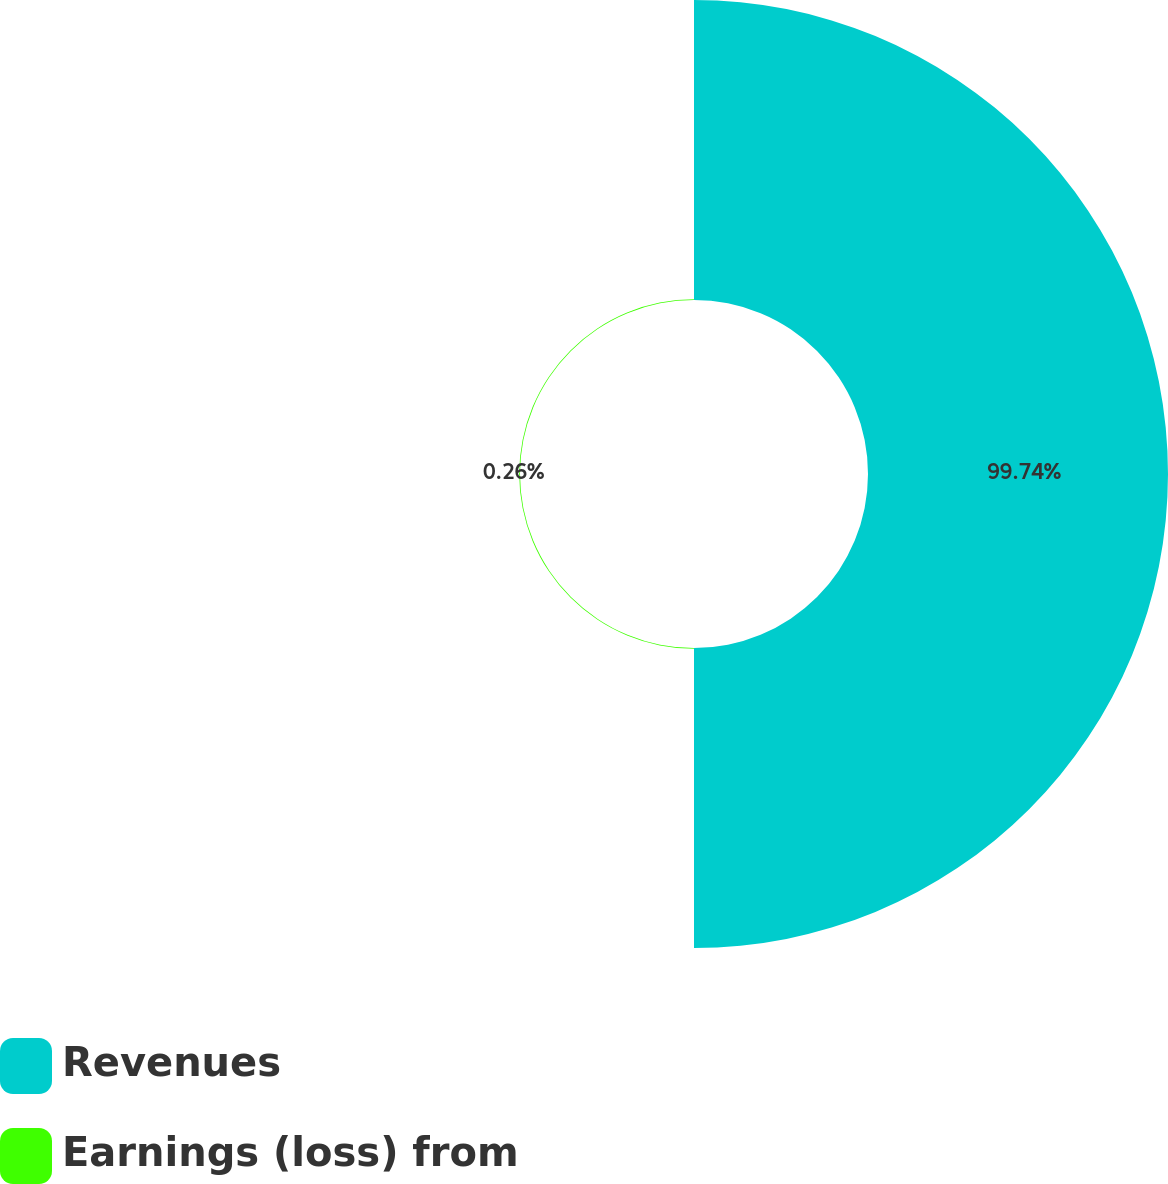Convert chart. <chart><loc_0><loc_0><loc_500><loc_500><pie_chart><fcel>Revenues<fcel>Earnings (loss) from<nl><fcel>99.74%<fcel>0.26%<nl></chart> 